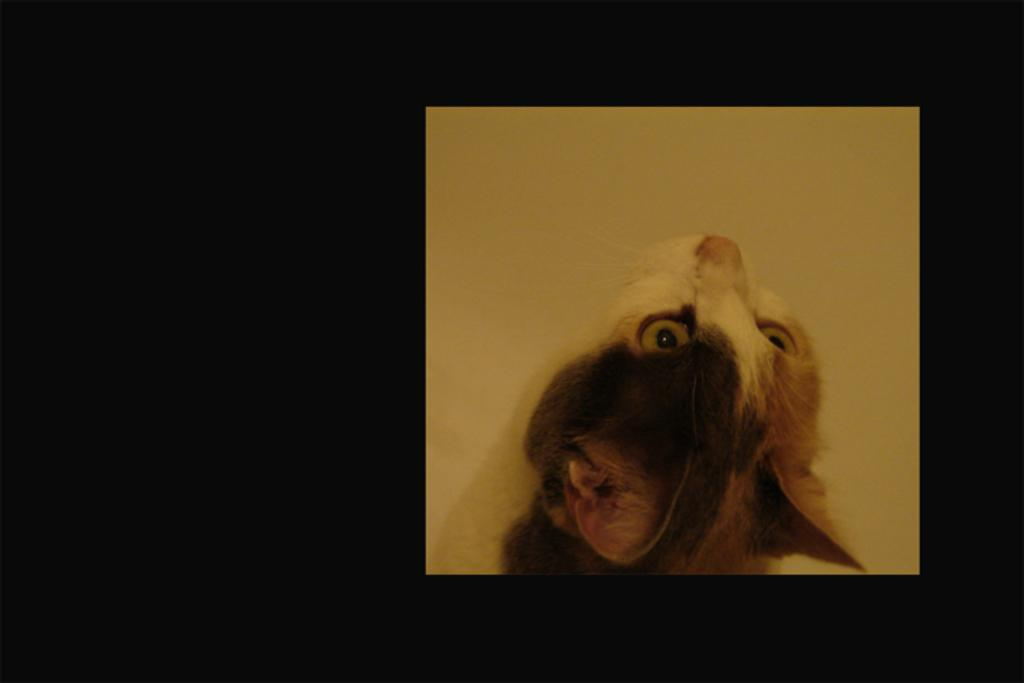What type of living creature can be seen in the image? There is an animal visible in the image. What type of can does the fireman use to extinguish the earth in the image? There is no fireman, can, or earth present in the image. The image only contains an animal. 